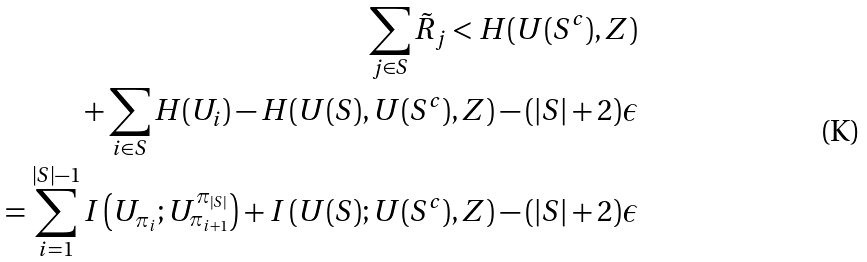Convert formula to latex. <formula><loc_0><loc_0><loc_500><loc_500>\sum _ { j \in S } \tilde { R } _ { j } < H ( U ( S ^ { c } ) , Z ) \\ + \sum _ { i \in S } H ( U _ { i } ) - H ( U ( S ) , U ( S ^ { c } ) , Z ) - ( | S | + 2 ) \epsilon \\ = \sum _ { i = 1 } ^ { | S | - 1 } I \left ( U _ { \pi _ { i } } ; U _ { \pi _ { i + 1 } } ^ { \pi _ { | S | } } \right ) + I \left ( U ( S ) ; U ( S ^ { c } ) , Z \right ) - ( | S | + 2 ) \epsilon</formula> 